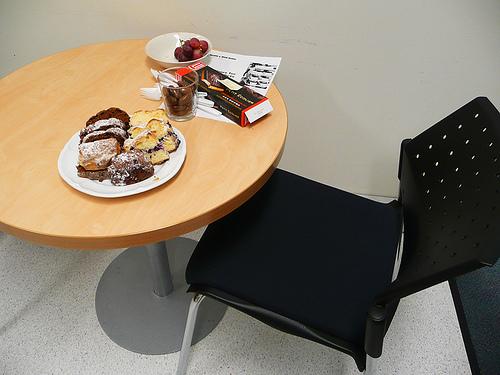How many table can you see?
Be succinct. 1. What type of food is it?
Be succinct. Dessert. What color is the chair?
Give a very brief answer. Black. 